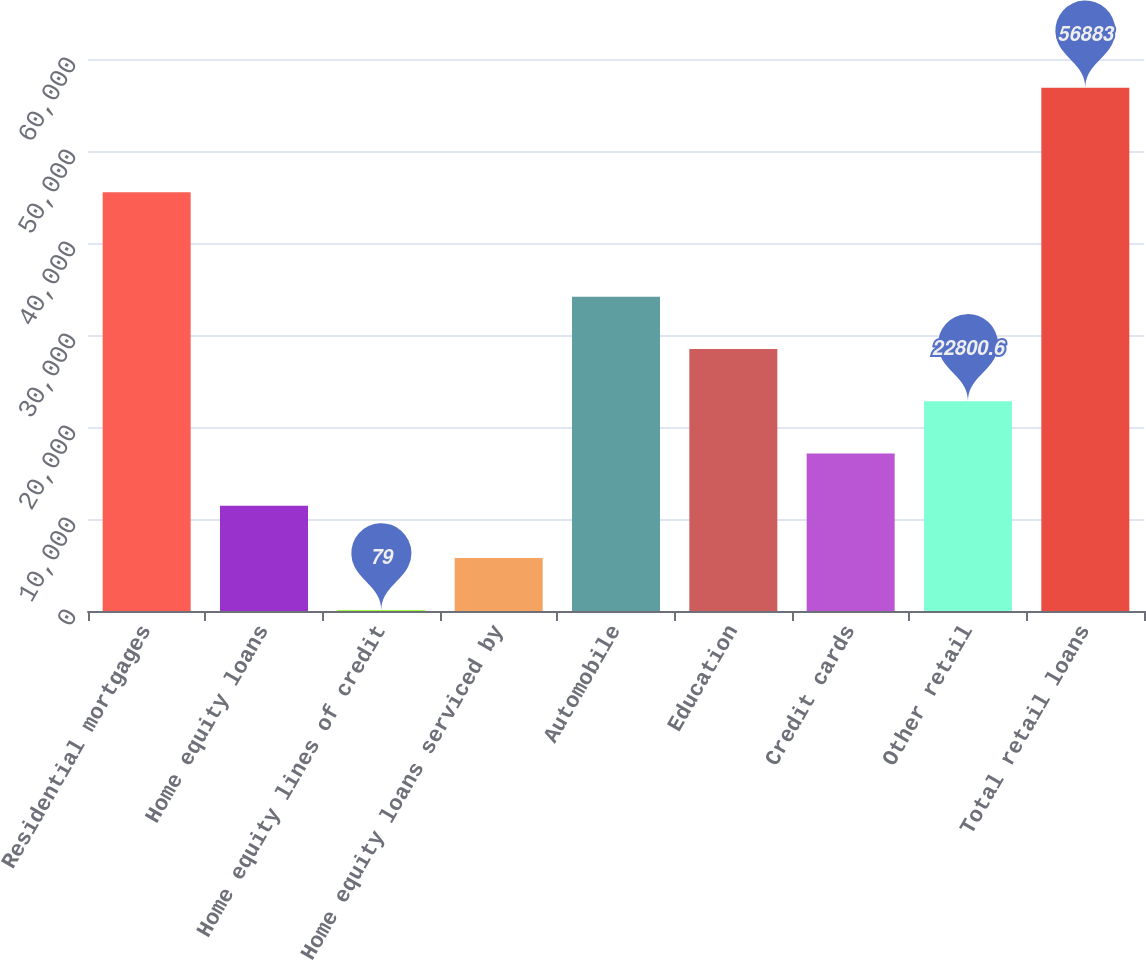<chart> <loc_0><loc_0><loc_500><loc_500><bar_chart><fcel>Residential mortgages<fcel>Home equity loans<fcel>Home equity lines of credit<fcel>Home equity loans serviced by<fcel>Automobile<fcel>Education<fcel>Credit cards<fcel>Other retail<fcel>Total retail loans<nl><fcel>45522.2<fcel>11439.8<fcel>79<fcel>5759.4<fcel>34161.4<fcel>28481<fcel>17120.2<fcel>22800.6<fcel>56883<nl></chart> 